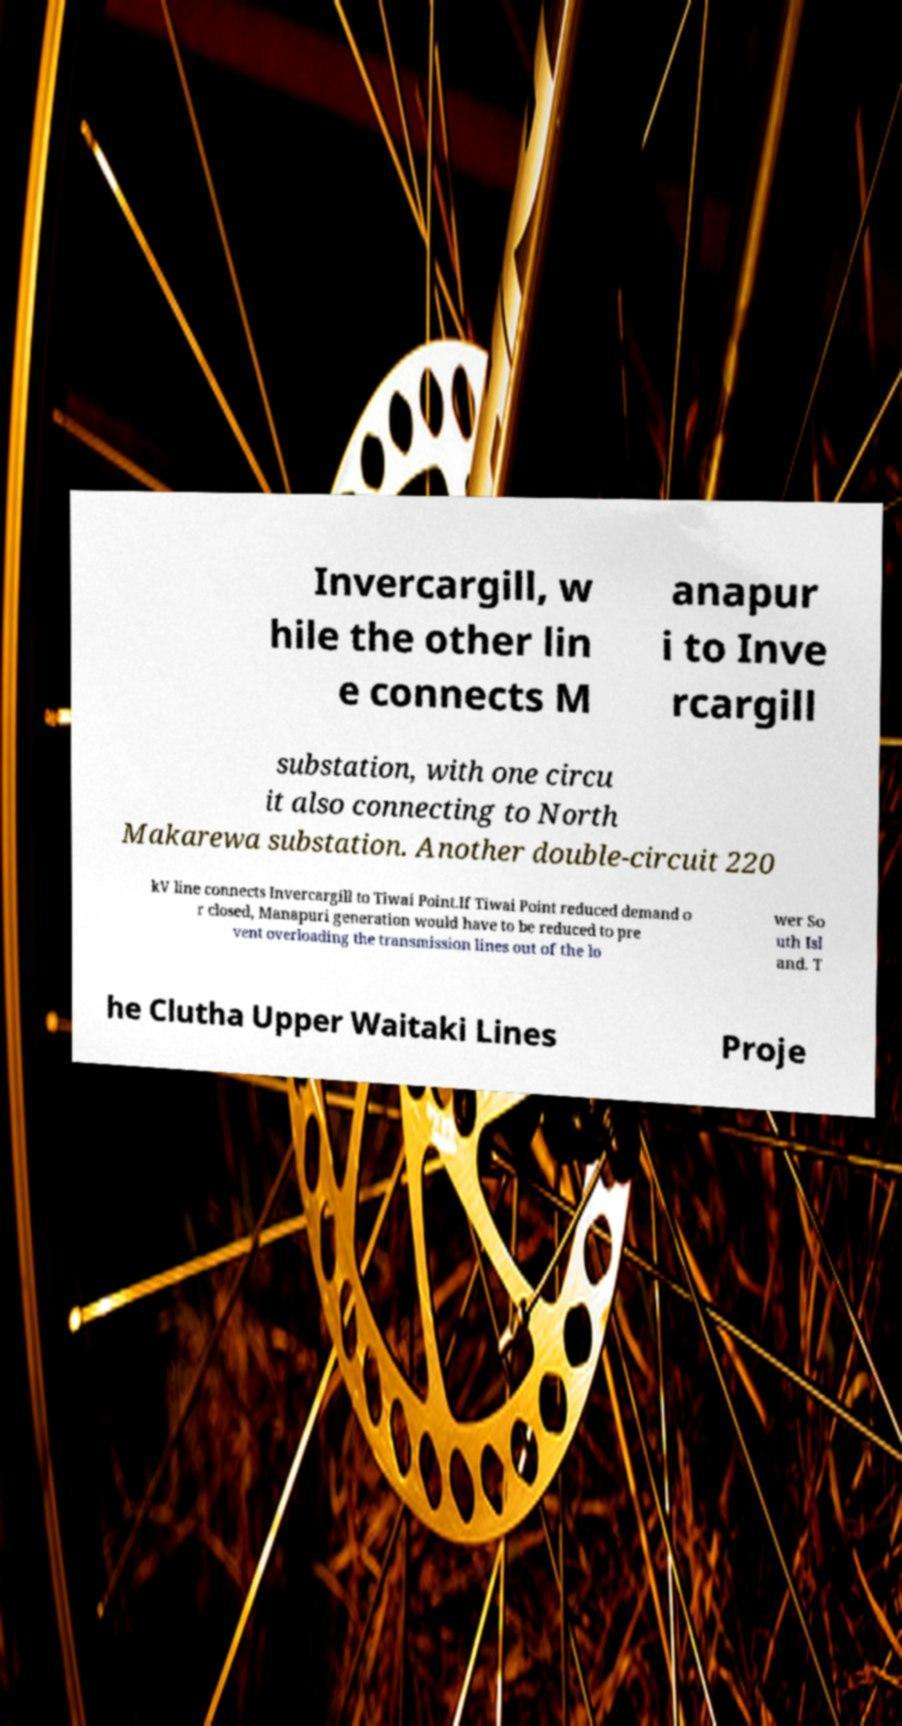What messages or text are displayed in this image? I need them in a readable, typed format. Invercargill, w hile the other lin e connects M anapur i to Inve rcargill substation, with one circu it also connecting to North Makarewa substation. Another double-circuit 220 kV line connects Invercargill to Tiwai Point.If Tiwai Point reduced demand o r closed, Manapuri generation would have to be reduced to pre vent overloading the transmission lines out of the lo wer So uth Isl and. T he Clutha Upper Waitaki Lines Proje 